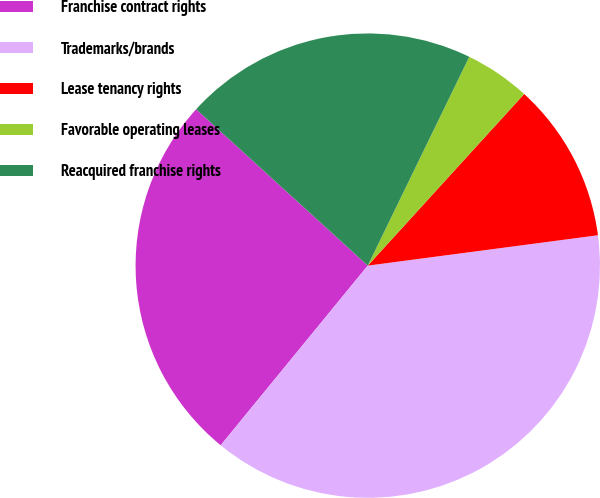Convert chart. <chart><loc_0><loc_0><loc_500><loc_500><pie_chart><fcel>Franchise contract rights<fcel>Trademarks/brands<fcel>Lease tenancy rights<fcel>Favorable operating leases<fcel>Reacquired franchise rights<nl><fcel>25.84%<fcel>38.01%<fcel>11.15%<fcel>4.56%<fcel>20.44%<nl></chart> 